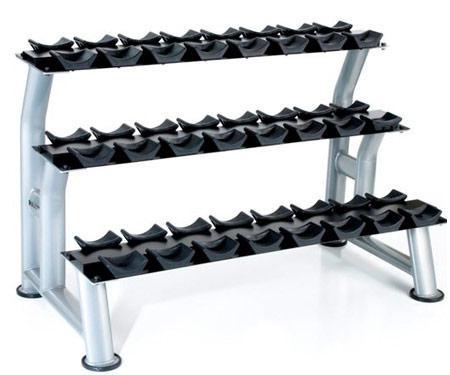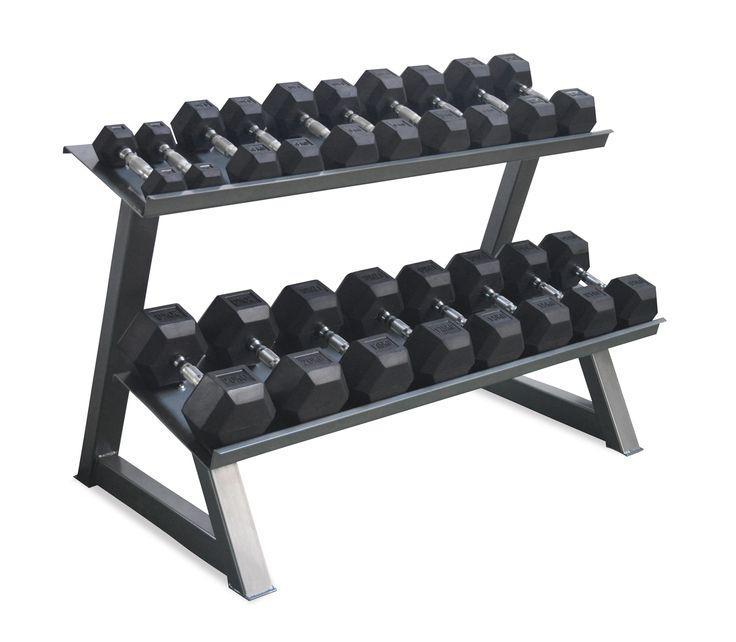The first image is the image on the left, the second image is the image on the right. Analyze the images presented: Is the assertion "There are six rows on weights with three rows in each image, and each image's rows of weights are facing opposite directions." valid? Answer yes or no. No. The first image is the image on the left, the second image is the image on the right. For the images displayed, is the sentence "One rack has three tiers to hold dumbbells, and the other rack has only two shelves for weights." factually correct? Answer yes or no. Yes. 